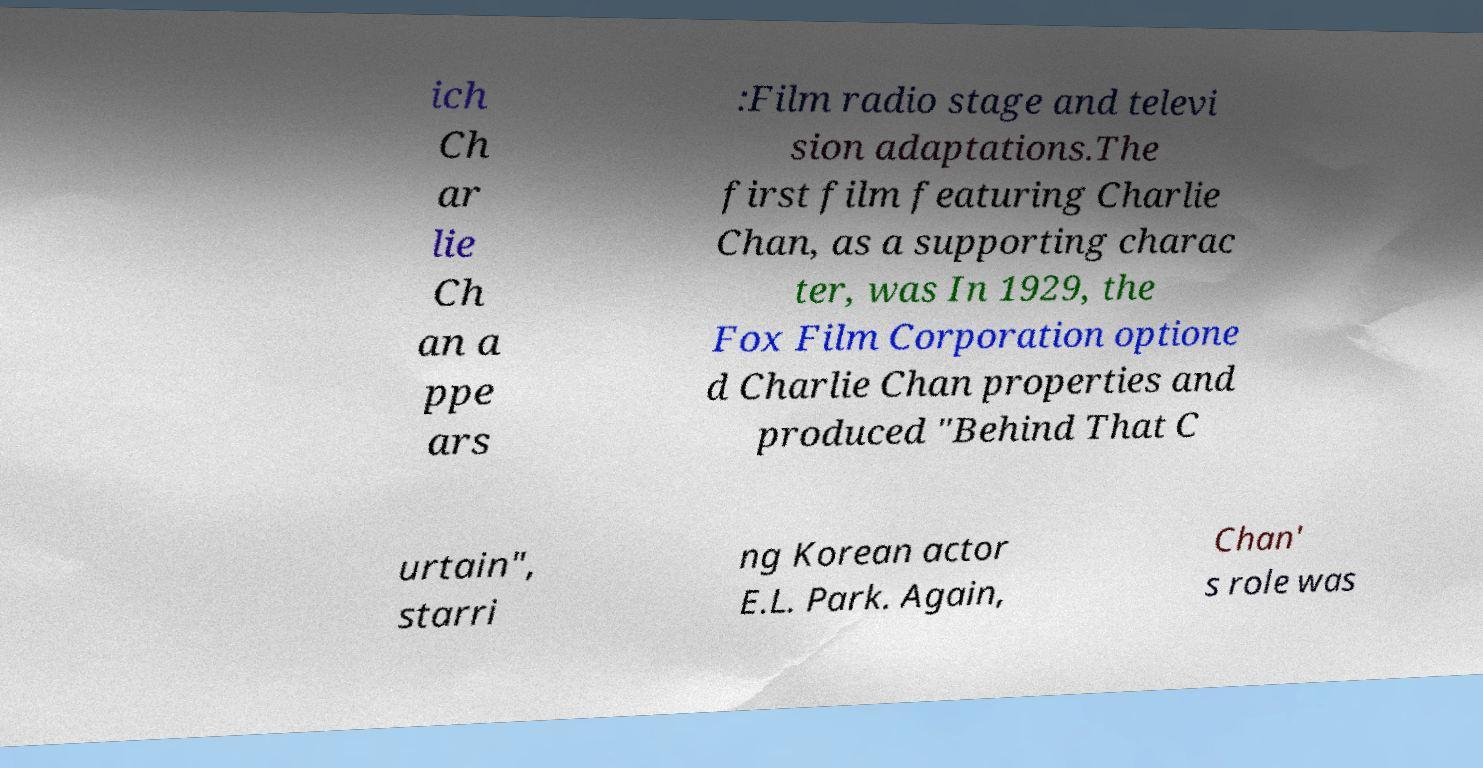For documentation purposes, I need the text within this image transcribed. Could you provide that? ich Ch ar lie Ch an a ppe ars :Film radio stage and televi sion adaptations.The first film featuring Charlie Chan, as a supporting charac ter, was In 1929, the Fox Film Corporation optione d Charlie Chan properties and produced "Behind That C urtain", starri ng Korean actor E.L. Park. Again, Chan' s role was 